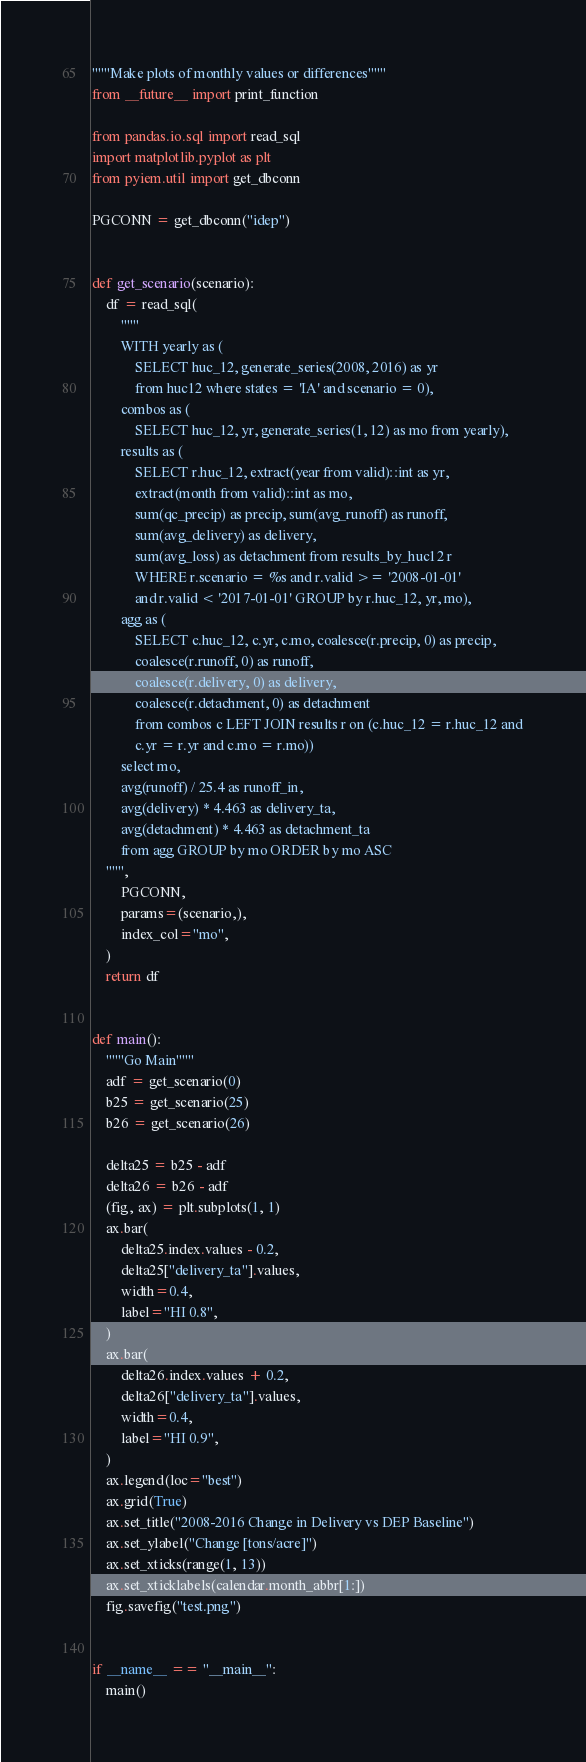Convert code to text. <code><loc_0><loc_0><loc_500><loc_500><_Python_>"""Make plots of monthly values or differences"""
from __future__ import print_function

from pandas.io.sql import read_sql
import matplotlib.pyplot as plt
from pyiem.util import get_dbconn

PGCONN = get_dbconn("idep")


def get_scenario(scenario):
    df = read_sql(
        """
        WITH yearly as (
            SELECT huc_12, generate_series(2008, 2016) as yr
            from huc12 where states = 'IA' and scenario = 0),
        combos as (
            SELECT huc_12, yr, generate_series(1, 12) as mo from yearly),
        results as (
            SELECT r.huc_12, extract(year from valid)::int as yr,
            extract(month from valid)::int as mo,
            sum(qc_precip) as precip, sum(avg_runoff) as runoff,
            sum(avg_delivery) as delivery,
            sum(avg_loss) as detachment from results_by_huc12 r
            WHERE r.scenario = %s and r.valid >= '2008-01-01'
            and r.valid < '2017-01-01' GROUP by r.huc_12, yr, mo),
        agg as (
            SELECT c.huc_12, c.yr, c.mo, coalesce(r.precip, 0) as precip,
            coalesce(r.runoff, 0) as runoff,
            coalesce(r.delivery, 0) as delivery,
            coalesce(r.detachment, 0) as detachment
            from combos c LEFT JOIN results r on (c.huc_12 = r.huc_12 and
            c.yr = r.yr and c.mo = r.mo))
        select mo,
        avg(runoff) / 25.4 as runoff_in,
        avg(delivery) * 4.463 as delivery_ta,
        avg(detachment) * 4.463 as detachment_ta
        from agg GROUP by mo ORDER by mo ASC
    """,
        PGCONN,
        params=(scenario,),
        index_col="mo",
    )
    return df


def main():
    """Go Main"""
    adf = get_scenario(0)
    b25 = get_scenario(25)
    b26 = get_scenario(26)

    delta25 = b25 - adf
    delta26 = b26 - adf
    (fig, ax) = plt.subplots(1, 1)
    ax.bar(
        delta25.index.values - 0.2,
        delta25["delivery_ta"].values,
        width=0.4,
        label="HI 0.8",
    )
    ax.bar(
        delta26.index.values + 0.2,
        delta26["delivery_ta"].values,
        width=0.4,
        label="HI 0.9",
    )
    ax.legend(loc="best")
    ax.grid(True)
    ax.set_title("2008-2016 Change in Delivery vs DEP Baseline")
    ax.set_ylabel("Change [tons/acre]")
    ax.set_xticks(range(1, 13))
    ax.set_xticklabels(calendar.month_abbr[1:])
    fig.savefig("test.png")


if __name__ == "__main__":
    main()
</code> 